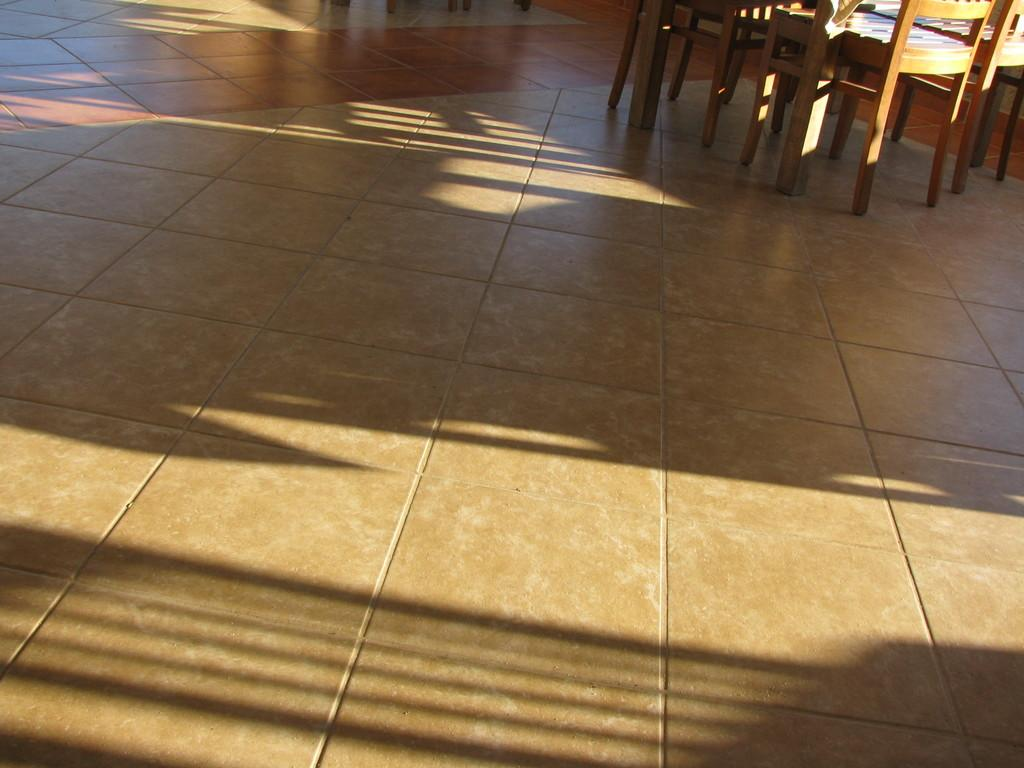What type of flooring is visible in the image? The floor in the image is covered with tiles. What type of furniture is on the floor in the image? There are wooden chairs on the floor in the image. What type of stitch is used to hold the cabbage together in the image? There is no cabbage present in the image, and therefore no stitching can be observed. 